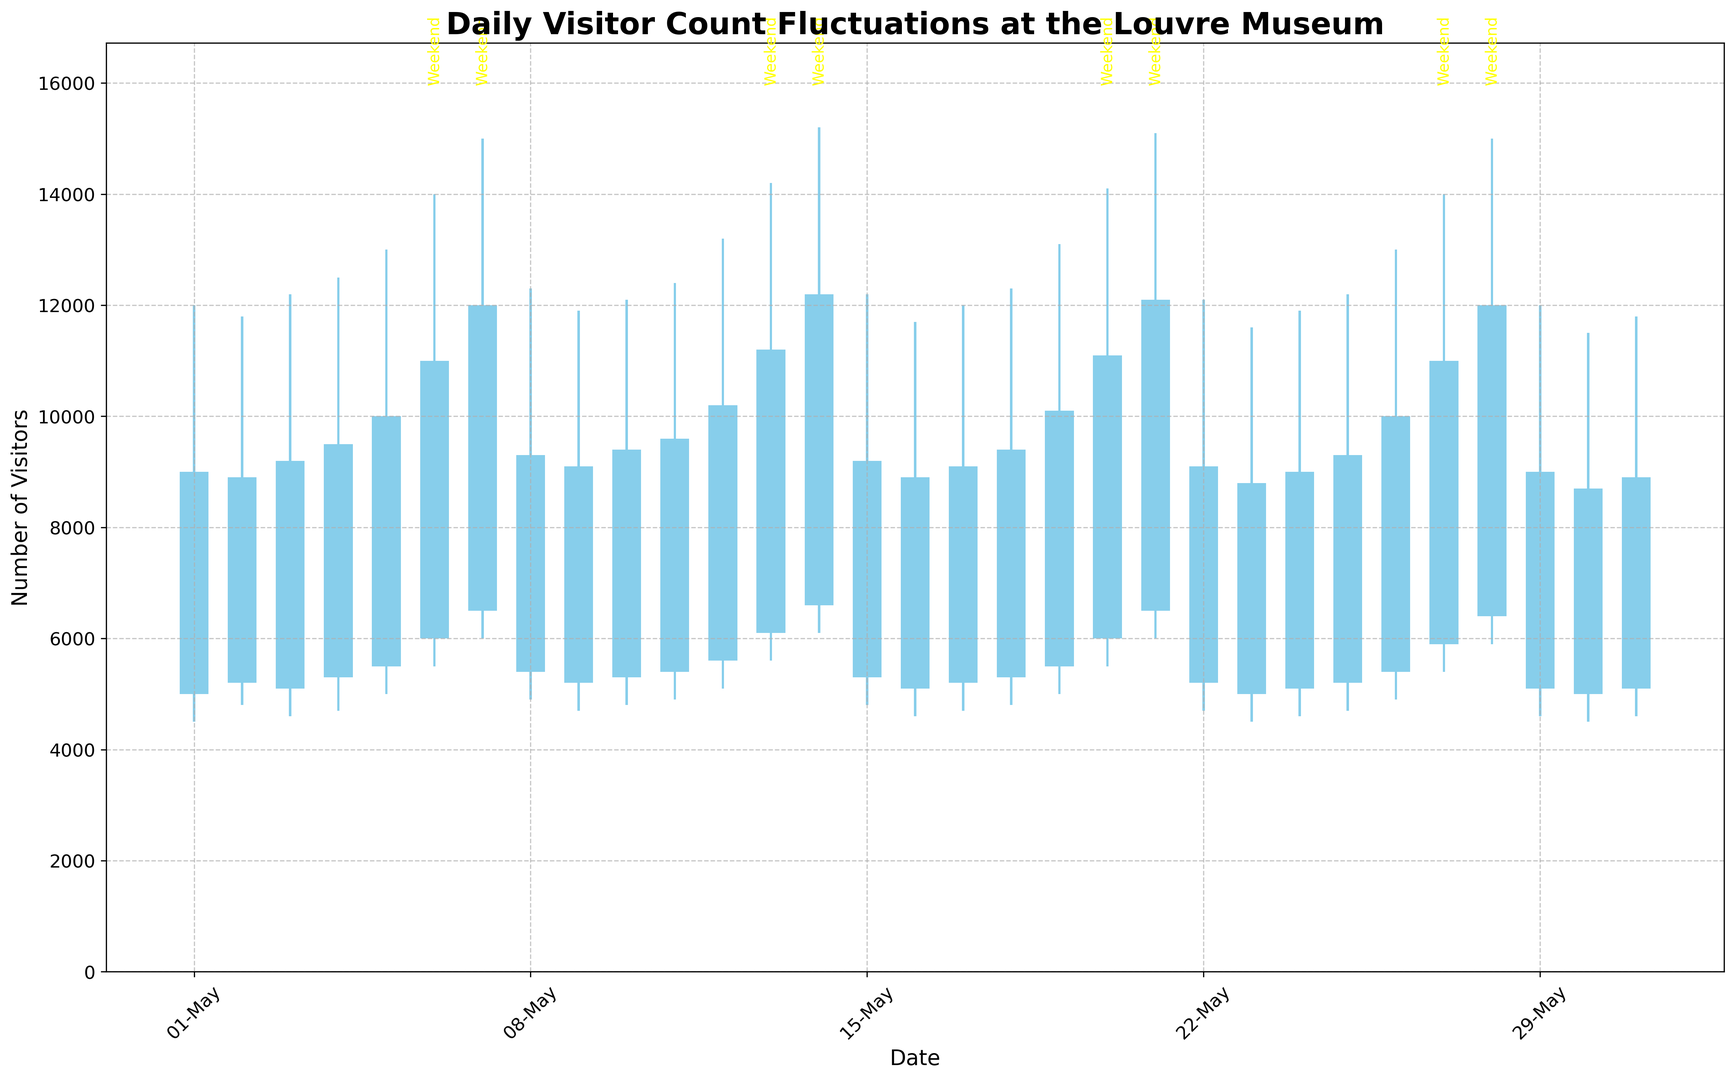what date had the highest peak visitor count? Look at the highest point on the chart for the entire month. Based on the data, May 14th had the highest peak with 15,200 visitors.
Answer: May 14th how much higher was the peak visitor count on May 14th compared to May 1st? On May 14th, the peak visitor count was 15,200, whereas on May 1st it was 12,000. The difference is 15,200 - 12,000 = 3,200 visitors.
Answer: 3,200 visitors Which days showed higher closing counts than opening counts? Look for the candlesticks that are blue, indicating closing counts were higher than opening counts. Some of these days are May 2nd, May 3rd, and May 4th.
Answer: May 2nd, May 3rd, May 4th (among others) What was the average closing visitor count during weekends? Identify dates that fall on the weekends, then sum their closing counts and divide by the number of weekends. May 6, 7, 13, 14, 20, 21, 27, and 28 are weekends, with closing counts of 11,000, 12,000, 11,200, 12,200, 11,100, 12,100, 11,000, and 12,000 respectively. The sum is 92,600, and there are 8 weekend days. So, the average is 92,600 / 8 = 11,575 visitors.
Answer: 11,575 visitors On which dates did the Louvre have a lower closing count compared to the opening count, and what color represents these days? Look for candlesticks that are red, indicating lower closing counts than opening counts. These days include May 5th and May 8th. The red color represents these days.
Answer: May 5th, May 8th, red 